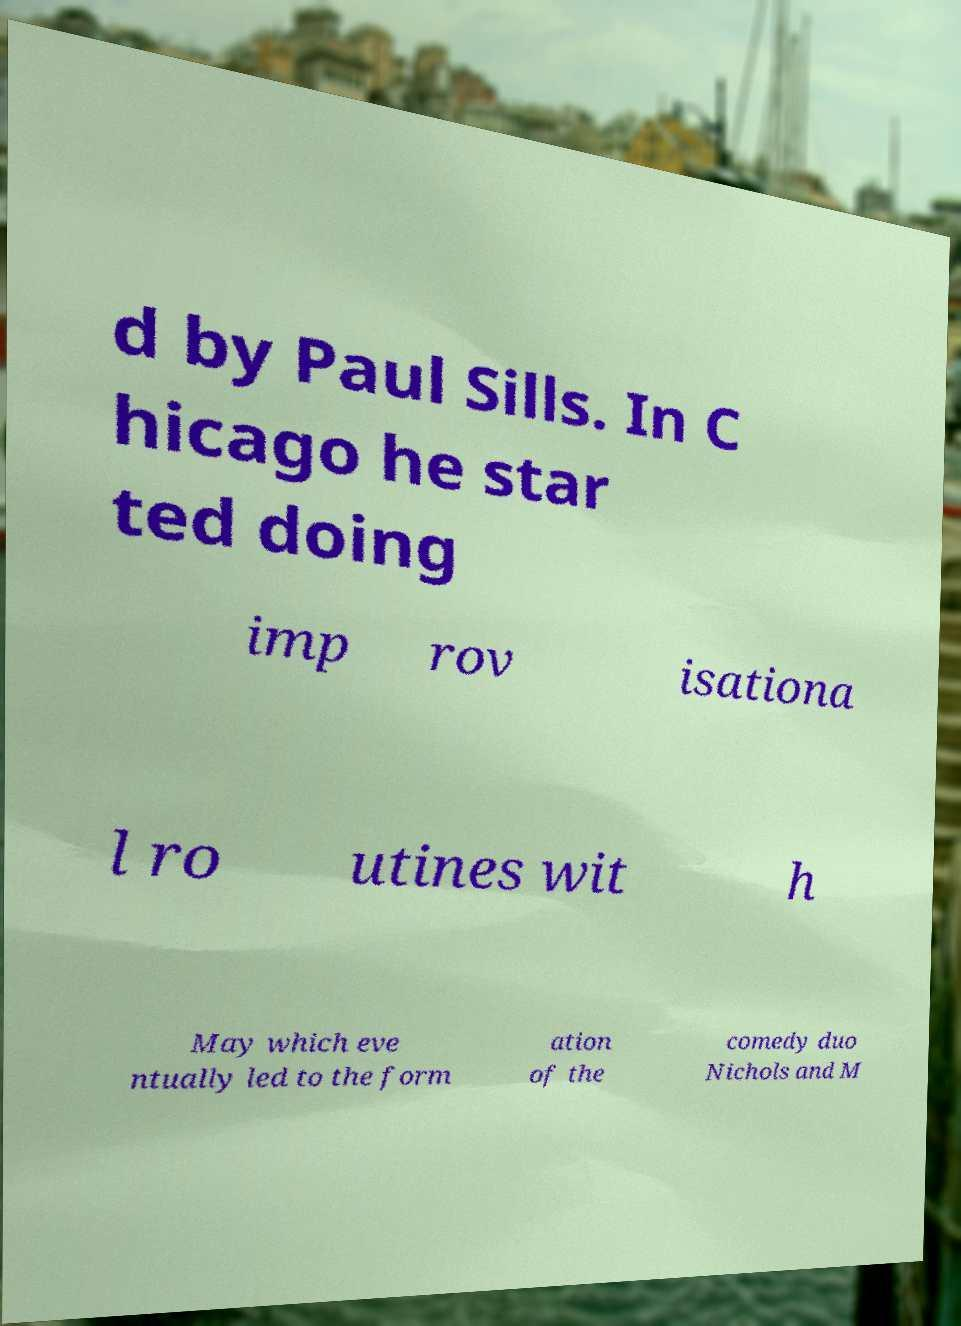Can you accurately transcribe the text from the provided image for me? d by Paul Sills. In C hicago he star ted doing imp rov isationa l ro utines wit h May which eve ntually led to the form ation of the comedy duo Nichols and M 